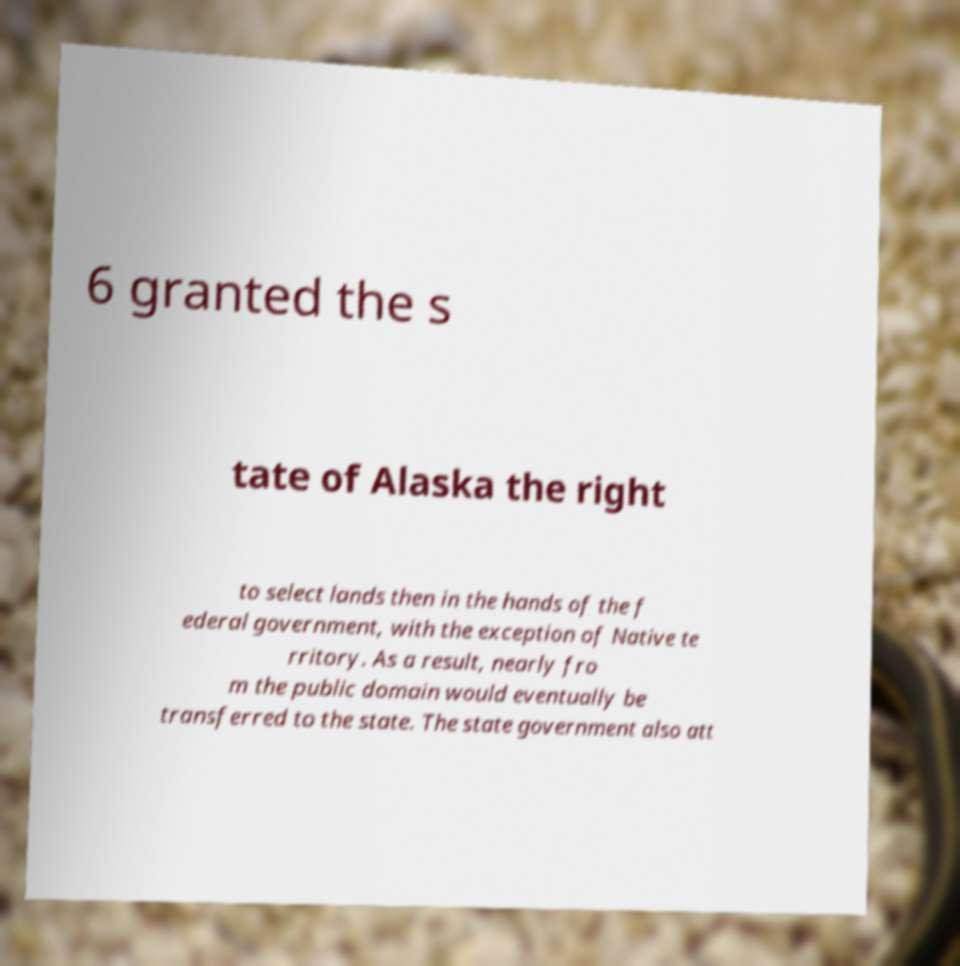I need the written content from this picture converted into text. Can you do that? 6 granted the s tate of Alaska the right to select lands then in the hands of the f ederal government, with the exception of Native te rritory. As a result, nearly fro m the public domain would eventually be transferred to the state. The state government also att 